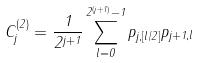Convert formula to latex. <formula><loc_0><loc_0><loc_500><loc_500>C ^ { ( 2 ) } _ { j } = \frac { 1 } { 2 ^ { j + 1 } } \sum _ { l = 0 } ^ { 2 ^ { ( j + 1 ) } - 1 } p _ { j , [ l / 2 ] } p _ { j + 1 , l }</formula> 